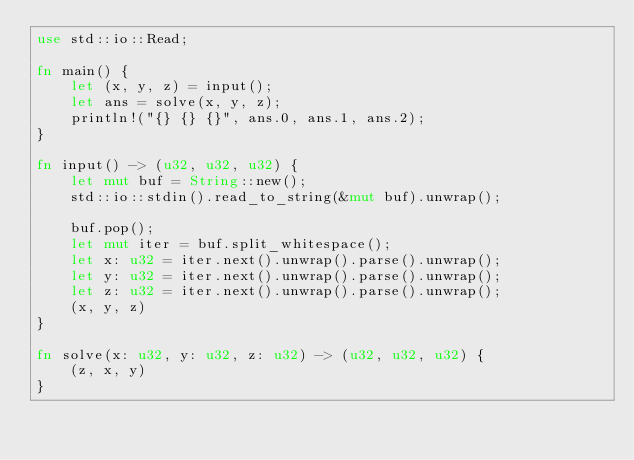<code> <loc_0><loc_0><loc_500><loc_500><_Rust_>use std::io::Read;

fn main() {
    let (x, y, z) = input();
    let ans = solve(x, y, z);
    println!("{} {} {}", ans.0, ans.1, ans.2);
}

fn input() -> (u32, u32, u32) {
    let mut buf = String::new();
    std::io::stdin().read_to_string(&mut buf).unwrap();

    buf.pop();
    let mut iter = buf.split_whitespace();
    let x: u32 = iter.next().unwrap().parse().unwrap();
    let y: u32 = iter.next().unwrap().parse().unwrap();
    let z: u32 = iter.next().unwrap().parse().unwrap();
    (x, y, z)
}

fn solve(x: u32, y: u32, z: u32) -> (u32, u32, u32) {
    (z, x, y)
}
</code> 